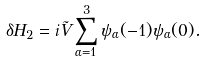<formula> <loc_0><loc_0><loc_500><loc_500>\delta H _ { 2 } = i \tilde { V } \sum _ { \alpha = 1 } ^ { 3 } \psi _ { \alpha } ( - 1 ) \psi _ { \alpha } ( 0 ) .</formula> 